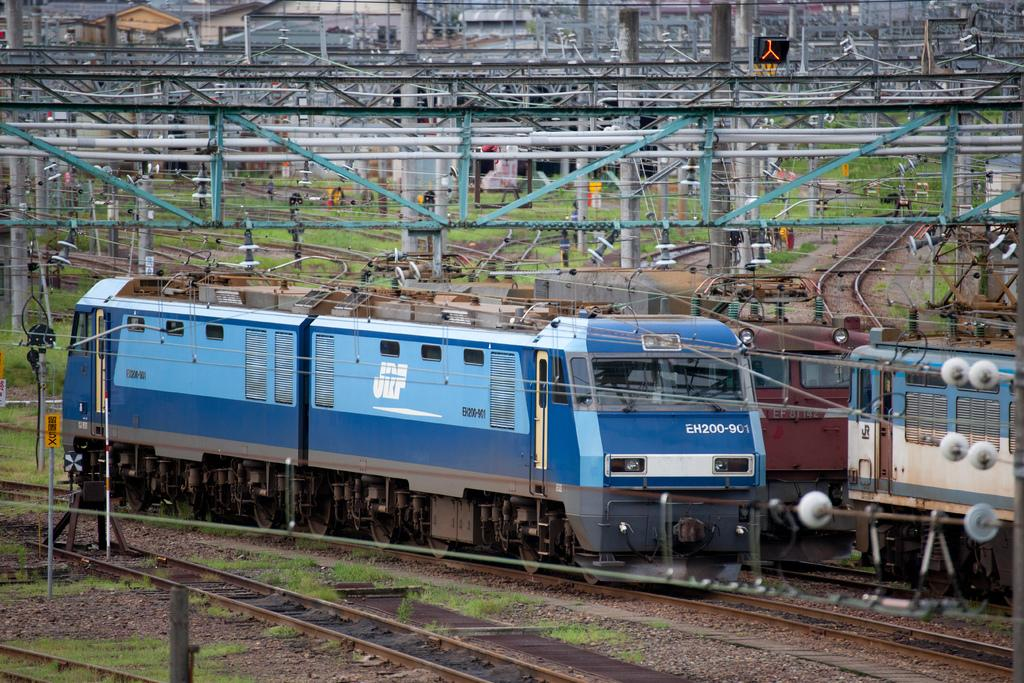<image>
Give a short and clear explanation of the subsequent image. A railroad train with the numbers EH200-901 on the front. 